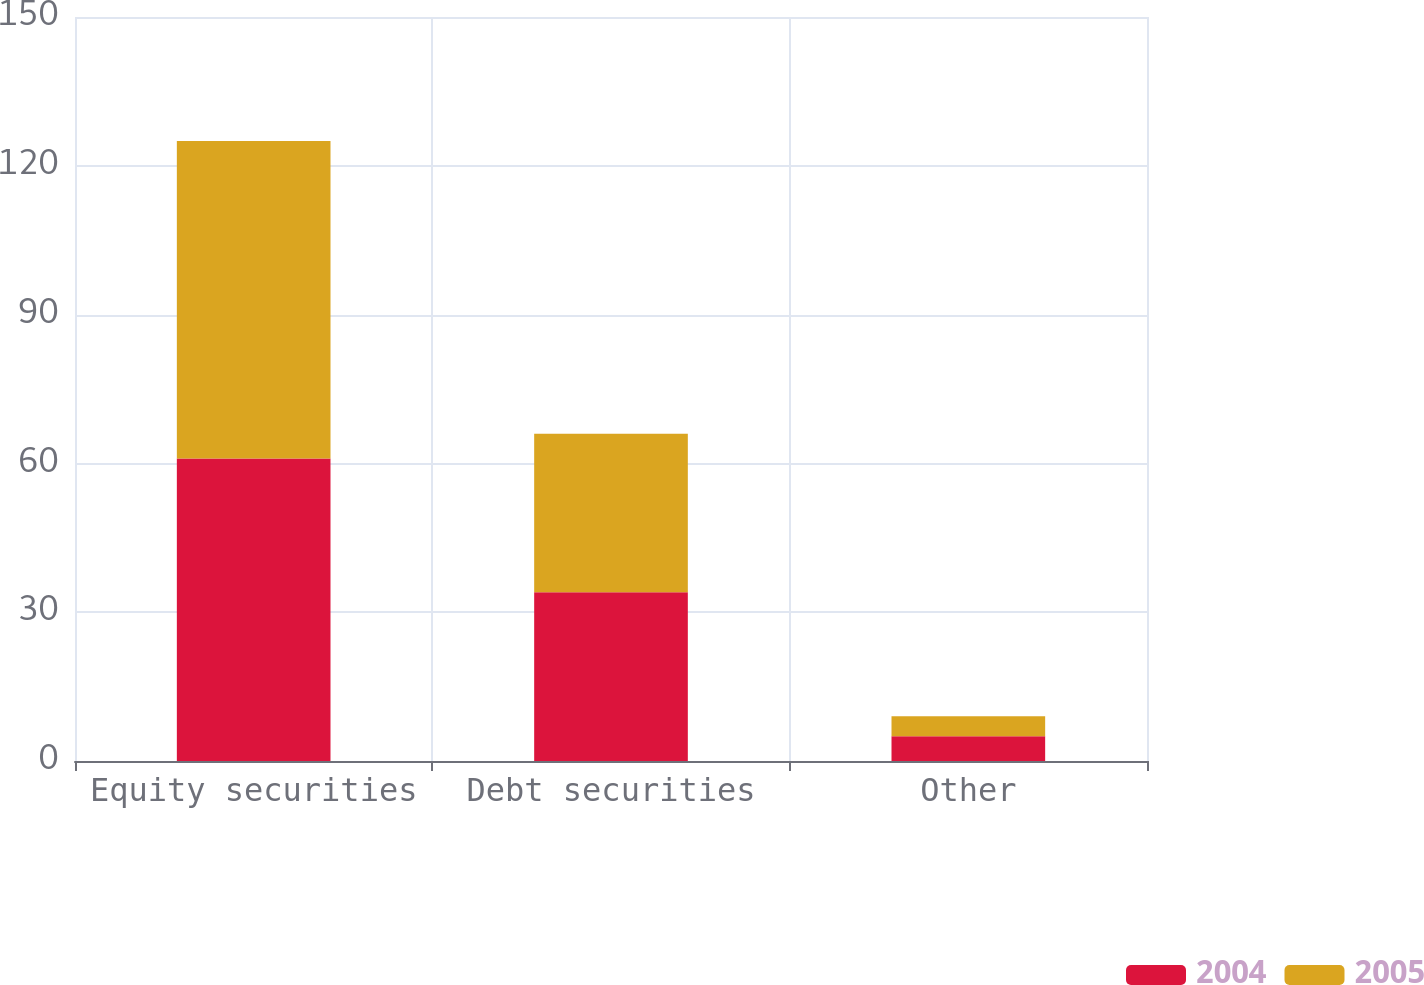Convert chart. <chart><loc_0><loc_0><loc_500><loc_500><stacked_bar_chart><ecel><fcel>Equity securities<fcel>Debt securities<fcel>Other<nl><fcel>2004<fcel>61<fcel>34<fcel>5<nl><fcel>2005<fcel>64<fcel>32<fcel>4<nl></chart> 